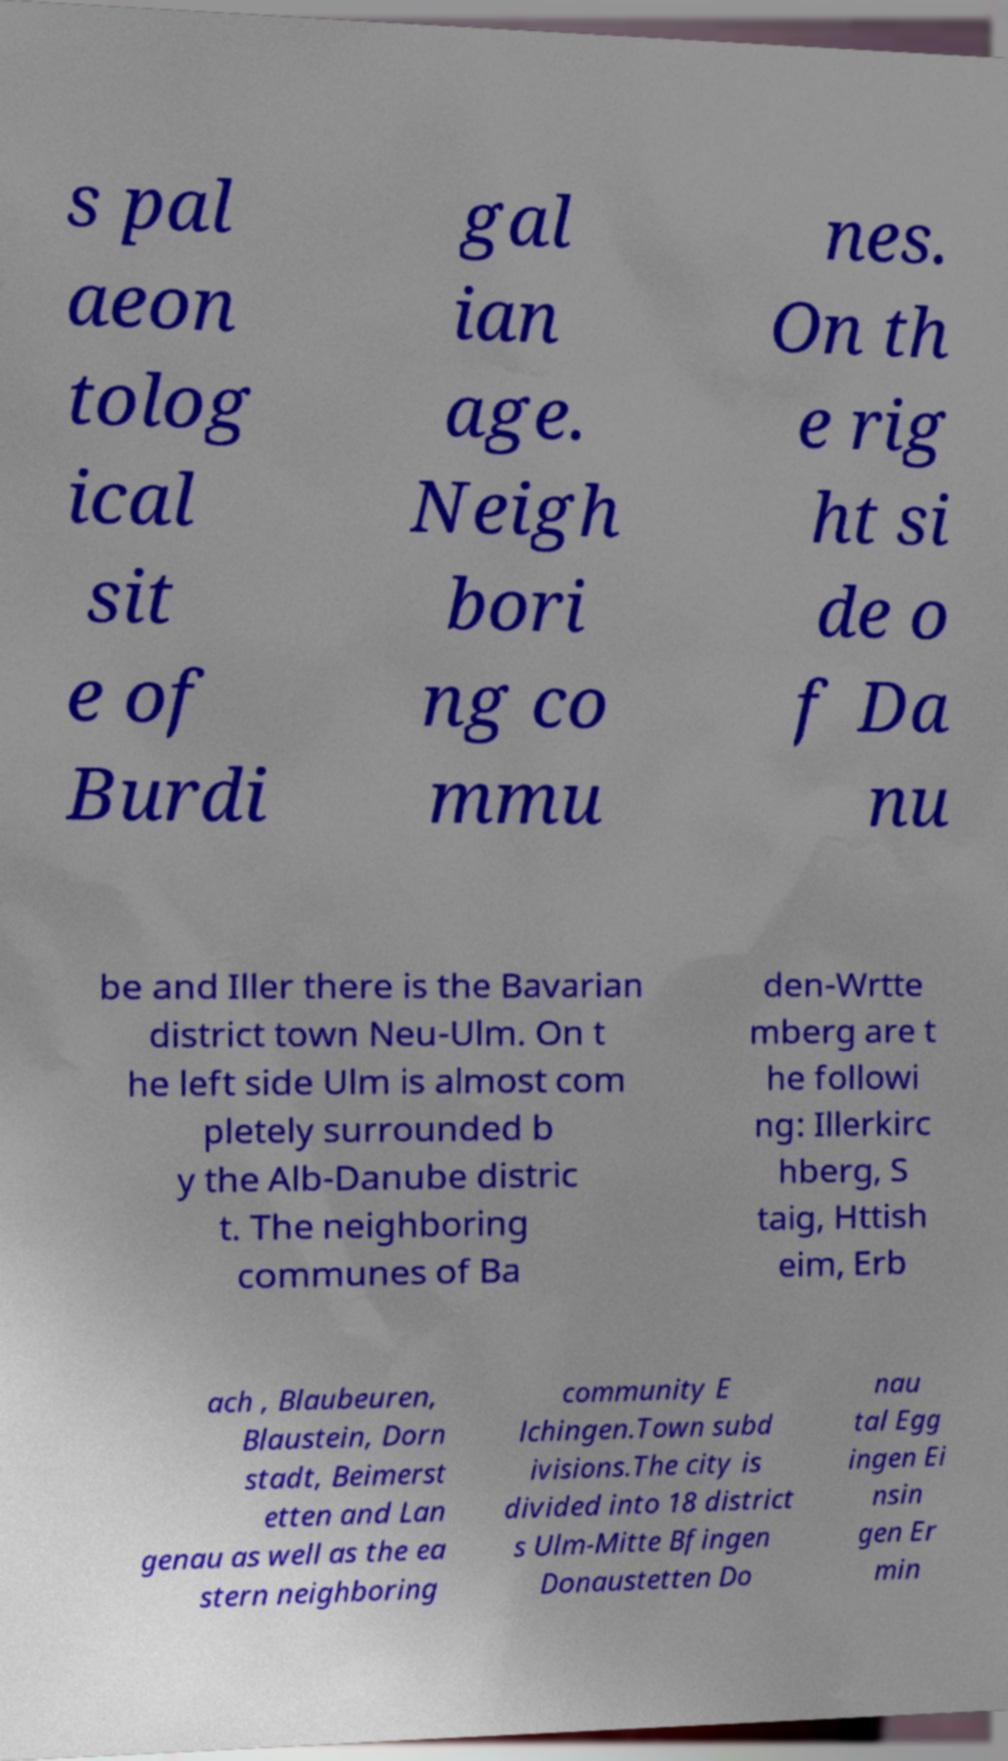There's text embedded in this image that I need extracted. Can you transcribe it verbatim? s pal aeon tolog ical sit e of Burdi gal ian age. Neigh bori ng co mmu nes. On th e rig ht si de o f Da nu be and Iller there is the Bavarian district town Neu-Ulm. On t he left side Ulm is almost com pletely surrounded b y the Alb-Danube distric t. The neighboring communes of Ba den-Wrtte mberg are t he followi ng: Illerkirc hberg, S taig, Httish eim, Erb ach , Blaubeuren, Blaustein, Dorn stadt, Beimerst etten and Lan genau as well as the ea stern neighboring community E lchingen.Town subd ivisions.The city is divided into 18 district s Ulm-Mitte Bfingen Donaustetten Do nau tal Egg ingen Ei nsin gen Er min 